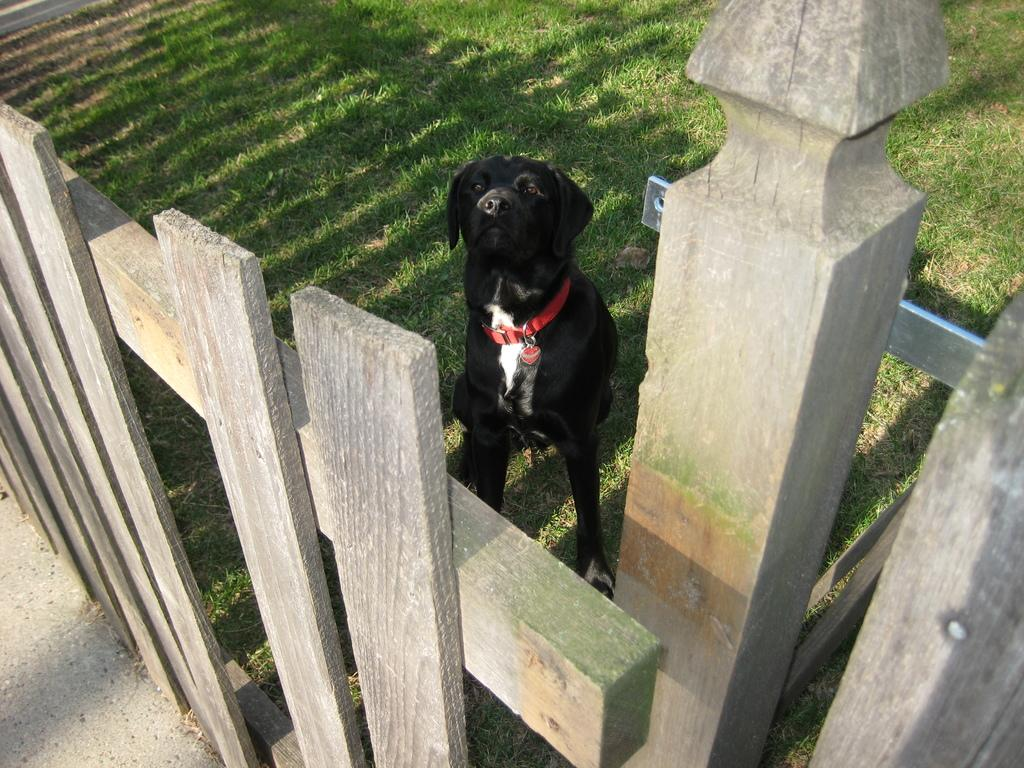What type of structure can be seen in the image? There is a fencing in the image. Can you describe the materials used for the structure? There is a metal object attached to a wooden object in the image. What type of terrain is visible in the image? There is grassy land visible in the image. Are there any animals present in the image? Yes, there is a dog in the image. What type of match is being held in the image? There is no match being held in the image; it features a fencing with a metal and wooden object attached. Can you tell me how many members are in the committee depicted in the image? There is no committee present in the image; it only shows a fencing, a metal and wooden object, grassy land, and a dog. 